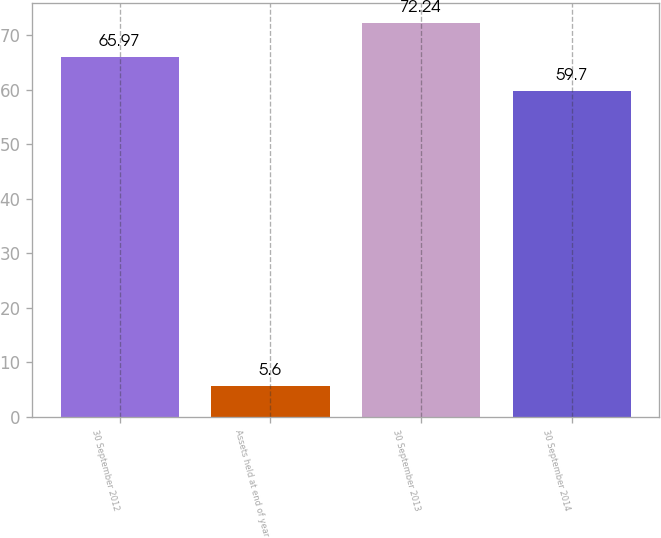Convert chart to OTSL. <chart><loc_0><loc_0><loc_500><loc_500><bar_chart><fcel>30 September 2012<fcel>Assets held at end of year<fcel>30 September 2013<fcel>30 September 2014<nl><fcel>65.97<fcel>5.6<fcel>72.24<fcel>59.7<nl></chart> 